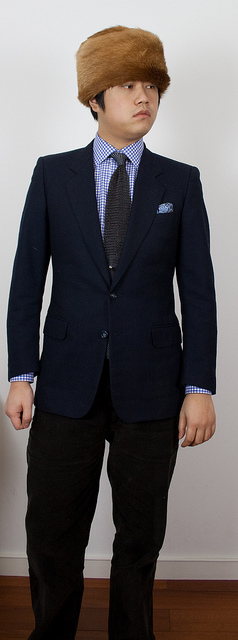<image>Which button is undone? I don't know which button is undone. It can be either the top or the bottom one. Which button is undone? It is ambiguous which button is undone. It can be the top or the bottom button. 